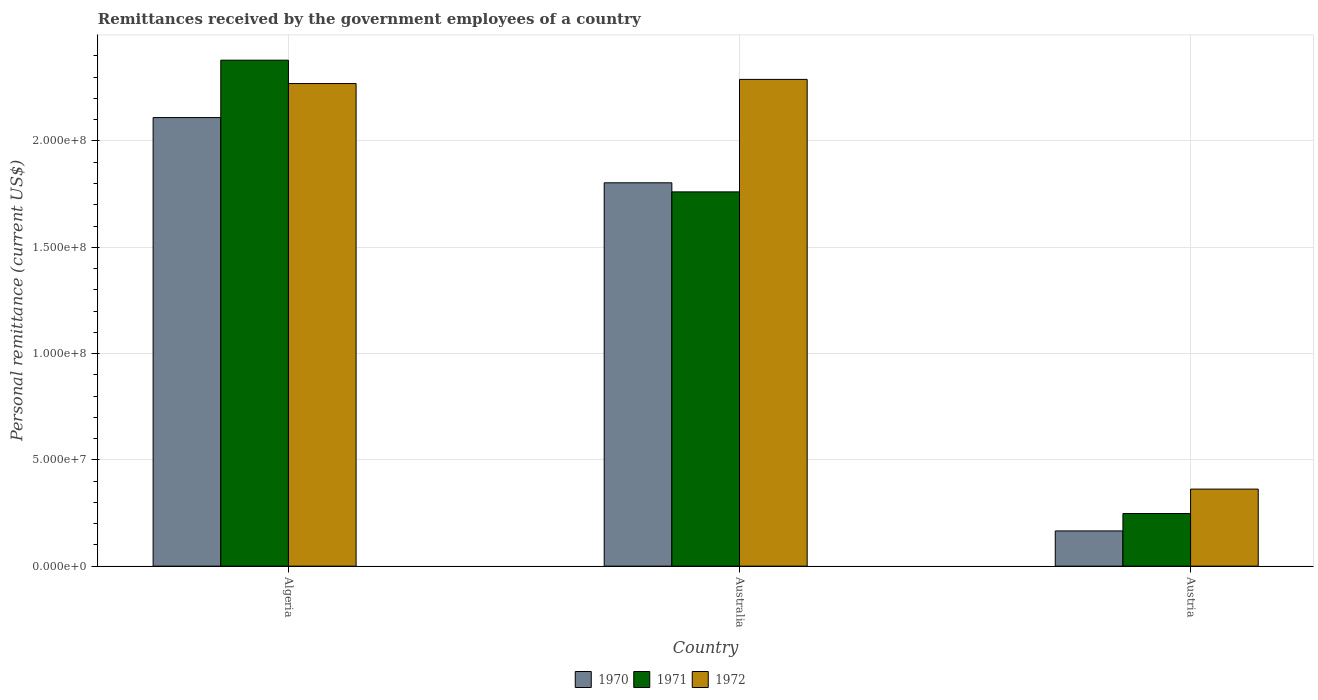How many groups of bars are there?
Provide a short and direct response. 3. Are the number of bars on each tick of the X-axis equal?
Your answer should be very brief. Yes. How many bars are there on the 1st tick from the left?
Provide a short and direct response. 3. How many bars are there on the 1st tick from the right?
Make the answer very short. 3. What is the label of the 3rd group of bars from the left?
Your answer should be compact. Austria. What is the remittances received by the government employees in 1970 in Australia?
Make the answer very short. 1.80e+08. Across all countries, what is the maximum remittances received by the government employees in 1970?
Your answer should be very brief. 2.11e+08. Across all countries, what is the minimum remittances received by the government employees in 1970?
Ensure brevity in your answer.  1.66e+07. In which country was the remittances received by the government employees in 1971 minimum?
Offer a very short reply. Austria. What is the total remittances received by the government employees in 1972 in the graph?
Offer a very short reply. 4.92e+08. What is the difference between the remittances received by the government employees in 1971 in Australia and that in Austria?
Your answer should be compact. 1.51e+08. What is the difference between the remittances received by the government employees in 1970 in Austria and the remittances received by the government employees in 1972 in Australia?
Your answer should be compact. -2.12e+08. What is the average remittances received by the government employees in 1972 per country?
Your response must be concise. 1.64e+08. What is the difference between the remittances received by the government employees of/in 1971 and remittances received by the government employees of/in 1970 in Austria?
Provide a succinct answer. 8.18e+06. What is the ratio of the remittances received by the government employees in 1971 in Australia to that in Austria?
Provide a succinct answer. 7.11. Is the remittances received by the government employees in 1971 in Algeria less than that in Australia?
Your answer should be compact. No. What is the difference between the highest and the second highest remittances received by the government employees in 1970?
Provide a succinct answer. 1.94e+08. What is the difference between the highest and the lowest remittances received by the government employees in 1970?
Your answer should be compact. 1.94e+08. In how many countries, is the remittances received by the government employees in 1971 greater than the average remittances received by the government employees in 1971 taken over all countries?
Provide a short and direct response. 2. Is the sum of the remittances received by the government employees in 1970 in Australia and Austria greater than the maximum remittances received by the government employees in 1971 across all countries?
Keep it short and to the point. No. What does the 1st bar from the right in Austria represents?
Provide a succinct answer. 1972. Is it the case that in every country, the sum of the remittances received by the government employees in 1972 and remittances received by the government employees in 1971 is greater than the remittances received by the government employees in 1970?
Provide a succinct answer. Yes. How many bars are there?
Your answer should be compact. 9. Are all the bars in the graph horizontal?
Provide a short and direct response. No. What is the difference between two consecutive major ticks on the Y-axis?
Your answer should be very brief. 5.00e+07. Are the values on the major ticks of Y-axis written in scientific E-notation?
Give a very brief answer. Yes. Does the graph contain any zero values?
Make the answer very short. No. Does the graph contain grids?
Your answer should be compact. Yes. Where does the legend appear in the graph?
Offer a terse response. Bottom center. How are the legend labels stacked?
Offer a terse response. Horizontal. What is the title of the graph?
Your answer should be very brief. Remittances received by the government employees of a country. Does "1988" appear as one of the legend labels in the graph?
Provide a short and direct response. No. What is the label or title of the X-axis?
Offer a terse response. Country. What is the label or title of the Y-axis?
Your answer should be compact. Personal remittance (current US$). What is the Personal remittance (current US$) of 1970 in Algeria?
Keep it short and to the point. 2.11e+08. What is the Personal remittance (current US$) in 1971 in Algeria?
Ensure brevity in your answer.  2.38e+08. What is the Personal remittance (current US$) in 1972 in Algeria?
Your response must be concise. 2.27e+08. What is the Personal remittance (current US$) in 1970 in Australia?
Keep it short and to the point. 1.80e+08. What is the Personal remittance (current US$) in 1971 in Australia?
Give a very brief answer. 1.76e+08. What is the Personal remittance (current US$) in 1972 in Australia?
Keep it short and to the point. 2.29e+08. What is the Personal remittance (current US$) of 1970 in Austria?
Offer a very short reply. 1.66e+07. What is the Personal remittance (current US$) in 1971 in Austria?
Offer a terse response. 2.48e+07. What is the Personal remittance (current US$) in 1972 in Austria?
Provide a succinct answer. 3.62e+07. Across all countries, what is the maximum Personal remittance (current US$) in 1970?
Your answer should be compact. 2.11e+08. Across all countries, what is the maximum Personal remittance (current US$) in 1971?
Provide a succinct answer. 2.38e+08. Across all countries, what is the maximum Personal remittance (current US$) of 1972?
Your answer should be very brief. 2.29e+08. Across all countries, what is the minimum Personal remittance (current US$) in 1970?
Offer a very short reply. 1.66e+07. Across all countries, what is the minimum Personal remittance (current US$) in 1971?
Ensure brevity in your answer.  2.48e+07. Across all countries, what is the minimum Personal remittance (current US$) of 1972?
Offer a terse response. 3.62e+07. What is the total Personal remittance (current US$) in 1970 in the graph?
Your answer should be very brief. 4.08e+08. What is the total Personal remittance (current US$) in 1971 in the graph?
Provide a succinct answer. 4.39e+08. What is the total Personal remittance (current US$) of 1972 in the graph?
Give a very brief answer. 4.92e+08. What is the difference between the Personal remittance (current US$) of 1970 in Algeria and that in Australia?
Your response must be concise. 3.07e+07. What is the difference between the Personal remittance (current US$) of 1971 in Algeria and that in Australia?
Your response must be concise. 6.20e+07. What is the difference between the Personal remittance (current US$) of 1972 in Algeria and that in Australia?
Make the answer very short. -1.96e+06. What is the difference between the Personal remittance (current US$) in 1970 in Algeria and that in Austria?
Make the answer very short. 1.94e+08. What is the difference between the Personal remittance (current US$) of 1971 in Algeria and that in Austria?
Your response must be concise. 2.13e+08. What is the difference between the Personal remittance (current US$) in 1972 in Algeria and that in Austria?
Your response must be concise. 1.91e+08. What is the difference between the Personal remittance (current US$) of 1970 in Australia and that in Austria?
Make the answer very short. 1.64e+08. What is the difference between the Personal remittance (current US$) of 1971 in Australia and that in Austria?
Ensure brevity in your answer.  1.51e+08. What is the difference between the Personal remittance (current US$) of 1972 in Australia and that in Austria?
Your answer should be compact. 1.93e+08. What is the difference between the Personal remittance (current US$) in 1970 in Algeria and the Personal remittance (current US$) in 1971 in Australia?
Your answer should be very brief. 3.50e+07. What is the difference between the Personal remittance (current US$) of 1970 in Algeria and the Personal remittance (current US$) of 1972 in Australia?
Give a very brief answer. -1.80e+07. What is the difference between the Personal remittance (current US$) in 1971 in Algeria and the Personal remittance (current US$) in 1972 in Australia?
Ensure brevity in your answer.  9.04e+06. What is the difference between the Personal remittance (current US$) of 1970 in Algeria and the Personal remittance (current US$) of 1971 in Austria?
Offer a terse response. 1.86e+08. What is the difference between the Personal remittance (current US$) of 1970 in Algeria and the Personal remittance (current US$) of 1972 in Austria?
Provide a short and direct response. 1.75e+08. What is the difference between the Personal remittance (current US$) in 1971 in Algeria and the Personal remittance (current US$) in 1972 in Austria?
Make the answer very short. 2.02e+08. What is the difference between the Personal remittance (current US$) in 1970 in Australia and the Personal remittance (current US$) in 1971 in Austria?
Your answer should be very brief. 1.56e+08. What is the difference between the Personal remittance (current US$) in 1970 in Australia and the Personal remittance (current US$) in 1972 in Austria?
Offer a terse response. 1.44e+08. What is the difference between the Personal remittance (current US$) in 1971 in Australia and the Personal remittance (current US$) in 1972 in Austria?
Provide a short and direct response. 1.40e+08. What is the average Personal remittance (current US$) in 1970 per country?
Give a very brief answer. 1.36e+08. What is the average Personal remittance (current US$) of 1971 per country?
Provide a short and direct response. 1.46e+08. What is the average Personal remittance (current US$) in 1972 per country?
Ensure brevity in your answer.  1.64e+08. What is the difference between the Personal remittance (current US$) in 1970 and Personal remittance (current US$) in 1971 in Algeria?
Your response must be concise. -2.70e+07. What is the difference between the Personal remittance (current US$) of 1970 and Personal remittance (current US$) of 1972 in Algeria?
Give a very brief answer. -1.60e+07. What is the difference between the Personal remittance (current US$) of 1971 and Personal remittance (current US$) of 1972 in Algeria?
Ensure brevity in your answer.  1.10e+07. What is the difference between the Personal remittance (current US$) of 1970 and Personal remittance (current US$) of 1971 in Australia?
Provide a short and direct response. 4.27e+06. What is the difference between the Personal remittance (current US$) of 1970 and Personal remittance (current US$) of 1972 in Australia?
Offer a very short reply. -4.86e+07. What is the difference between the Personal remittance (current US$) of 1971 and Personal remittance (current US$) of 1972 in Australia?
Your answer should be compact. -5.29e+07. What is the difference between the Personal remittance (current US$) in 1970 and Personal remittance (current US$) in 1971 in Austria?
Provide a short and direct response. -8.18e+06. What is the difference between the Personal remittance (current US$) in 1970 and Personal remittance (current US$) in 1972 in Austria?
Your response must be concise. -1.97e+07. What is the difference between the Personal remittance (current US$) of 1971 and Personal remittance (current US$) of 1972 in Austria?
Your answer should be compact. -1.15e+07. What is the ratio of the Personal remittance (current US$) of 1970 in Algeria to that in Australia?
Your answer should be very brief. 1.17. What is the ratio of the Personal remittance (current US$) of 1971 in Algeria to that in Australia?
Your response must be concise. 1.35. What is the ratio of the Personal remittance (current US$) of 1972 in Algeria to that in Australia?
Offer a very short reply. 0.99. What is the ratio of the Personal remittance (current US$) in 1970 in Algeria to that in Austria?
Ensure brevity in your answer.  12.73. What is the ratio of the Personal remittance (current US$) of 1971 in Algeria to that in Austria?
Keep it short and to the point. 9.61. What is the ratio of the Personal remittance (current US$) in 1972 in Algeria to that in Austria?
Provide a short and direct response. 6.26. What is the ratio of the Personal remittance (current US$) in 1970 in Australia to that in Austria?
Provide a succinct answer. 10.88. What is the ratio of the Personal remittance (current US$) of 1971 in Australia to that in Austria?
Your answer should be very brief. 7.11. What is the ratio of the Personal remittance (current US$) in 1972 in Australia to that in Austria?
Your answer should be very brief. 6.32. What is the difference between the highest and the second highest Personal remittance (current US$) of 1970?
Offer a terse response. 3.07e+07. What is the difference between the highest and the second highest Personal remittance (current US$) in 1971?
Make the answer very short. 6.20e+07. What is the difference between the highest and the second highest Personal remittance (current US$) of 1972?
Ensure brevity in your answer.  1.96e+06. What is the difference between the highest and the lowest Personal remittance (current US$) of 1970?
Offer a terse response. 1.94e+08. What is the difference between the highest and the lowest Personal remittance (current US$) of 1971?
Offer a very short reply. 2.13e+08. What is the difference between the highest and the lowest Personal remittance (current US$) of 1972?
Give a very brief answer. 1.93e+08. 